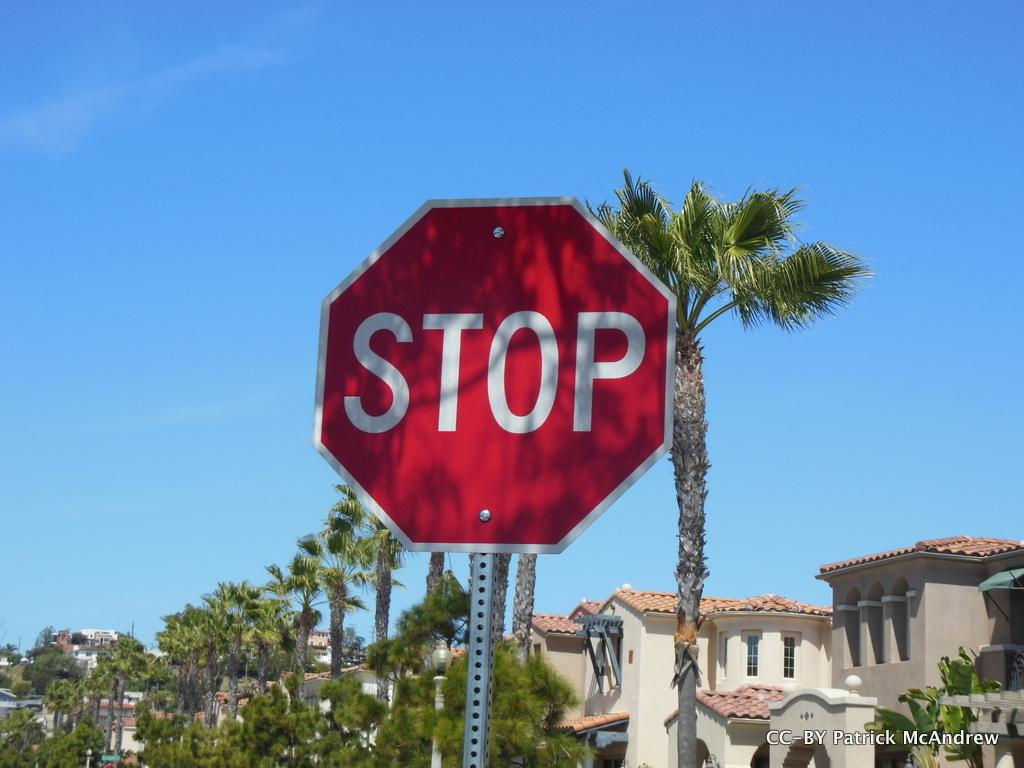<image>
Give a short and clear explanation of the subsequent image. Patrick McAndrew has documented a red stop sign. 